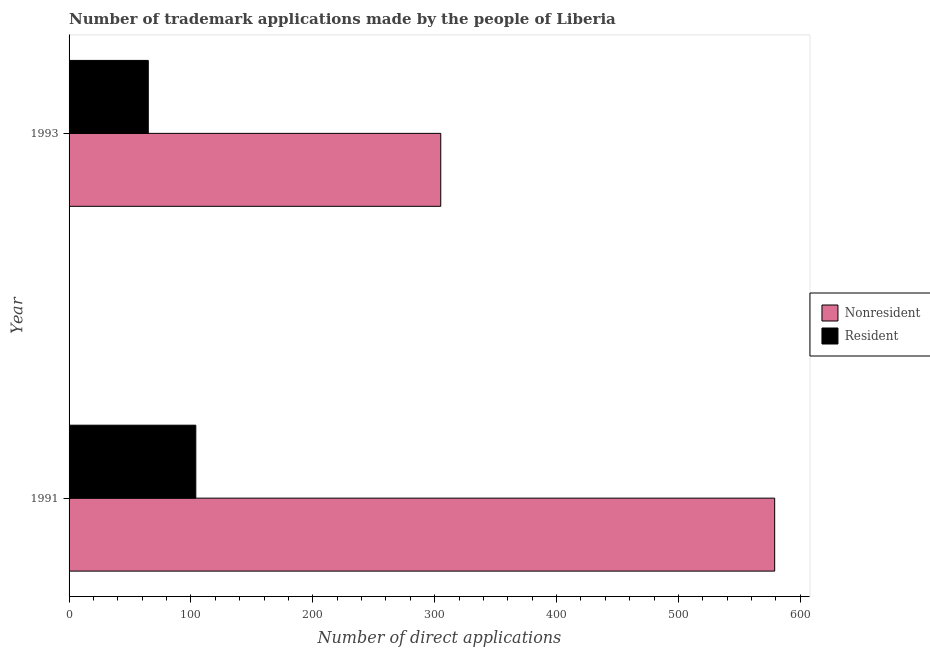How many groups of bars are there?
Your response must be concise. 2. What is the label of the 1st group of bars from the top?
Offer a very short reply. 1993. In how many cases, is the number of bars for a given year not equal to the number of legend labels?
Provide a short and direct response. 0. What is the number of trademark applications made by non residents in 1991?
Give a very brief answer. 579. Across all years, what is the maximum number of trademark applications made by non residents?
Give a very brief answer. 579. Across all years, what is the minimum number of trademark applications made by non residents?
Provide a succinct answer. 305. In which year was the number of trademark applications made by residents maximum?
Offer a terse response. 1991. What is the total number of trademark applications made by non residents in the graph?
Keep it short and to the point. 884. What is the difference between the number of trademark applications made by residents in 1991 and that in 1993?
Offer a very short reply. 39. What is the difference between the number of trademark applications made by residents in 1993 and the number of trademark applications made by non residents in 1991?
Give a very brief answer. -514. What is the average number of trademark applications made by residents per year?
Your answer should be very brief. 84.5. In the year 1993, what is the difference between the number of trademark applications made by residents and number of trademark applications made by non residents?
Give a very brief answer. -240. What is the ratio of the number of trademark applications made by non residents in 1991 to that in 1993?
Give a very brief answer. 1.9. Is the number of trademark applications made by residents in 1991 less than that in 1993?
Provide a short and direct response. No. In how many years, is the number of trademark applications made by residents greater than the average number of trademark applications made by residents taken over all years?
Give a very brief answer. 1. What does the 2nd bar from the top in 1993 represents?
Your response must be concise. Nonresident. What does the 2nd bar from the bottom in 1991 represents?
Offer a terse response. Resident. How many bars are there?
Give a very brief answer. 4. Are all the bars in the graph horizontal?
Ensure brevity in your answer.  Yes. How many years are there in the graph?
Your answer should be compact. 2. What is the difference between two consecutive major ticks on the X-axis?
Ensure brevity in your answer.  100. Does the graph contain any zero values?
Your answer should be compact. No. Does the graph contain grids?
Provide a short and direct response. No. Where does the legend appear in the graph?
Provide a short and direct response. Center right. What is the title of the graph?
Provide a succinct answer. Number of trademark applications made by the people of Liberia. What is the label or title of the X-axis?
Offer a terse response. Number of direct applications. What is the Number of direct applications of Nonresident in 1991?
Offer a very short reply. 579. What is the Number of direct applications in Resident in 1991?
Give a very brief answer. 104. What is the Number of direct applications of Nonresident in 1993?
Your answer should be very brief. 305. What is the Number of direct applications of Resident in 1993?
Provide a succinct answer. 65. Across all years, what is the maximum Number of direct applications of Nonresident?
Keep it short and to the point. 579. Across all years, what is the maximum Number of direct applications in Resident?
Your response must be concise. 104. Across all years, what is the minimum Number of direct applications of Nonresident?
Ensure brevity in your answer.  305. Across all years, what is the minimum Number of direct applications in Resident?
Provide a short and direct response. 65. What is the total Number of direct applications of Nonresident in the graph?
Offer a very short reply. 884. What is the total Number of direct applications of Resident in the graph?
Keep it short and to the point. 169. What is the difference between the Number of direct applications of Nonresident in 1991 and that in 1993?
Provide a short and direct response. 274. What is the difference between the Number of direct applications in Nonresident in 1991 and the Number of direct applications in Resident in 1993?
Ensure brevity in your answer.  514. What is the average Number of direct applications of Nonresident per year?
Your answer should be compact. 442. What is the average Number of direct applications of Resident per year?
Your answer should be very brief. 84.5. In the year 1991, what is the difference between the Number of direct applications in Nonresident and Number of direct applications in Resident?
Your answer should be very brief. 475. In the year 1993, what is the difference between the Number of direct applications in Nonresident and Number of direct applications in Resident?
Offer a very short reply. 240. What is the ratio of the Number of direct applications of Nonresident in 1991 to that in 1993?
Give a very brief answer. 1.9. What is the ratio of the Number of direct applications in Resident in 1991 to that in 1993?
Ensure brevity in your answer.  1.6. What is the difference between the highest and the second highest Number of direct applications in Nonresident?
Ensure brevity in your answer.  274. What is the difference between the highest and the lowest Number of direct applications in Nonresident?
Provide a succinct answer. 274. 